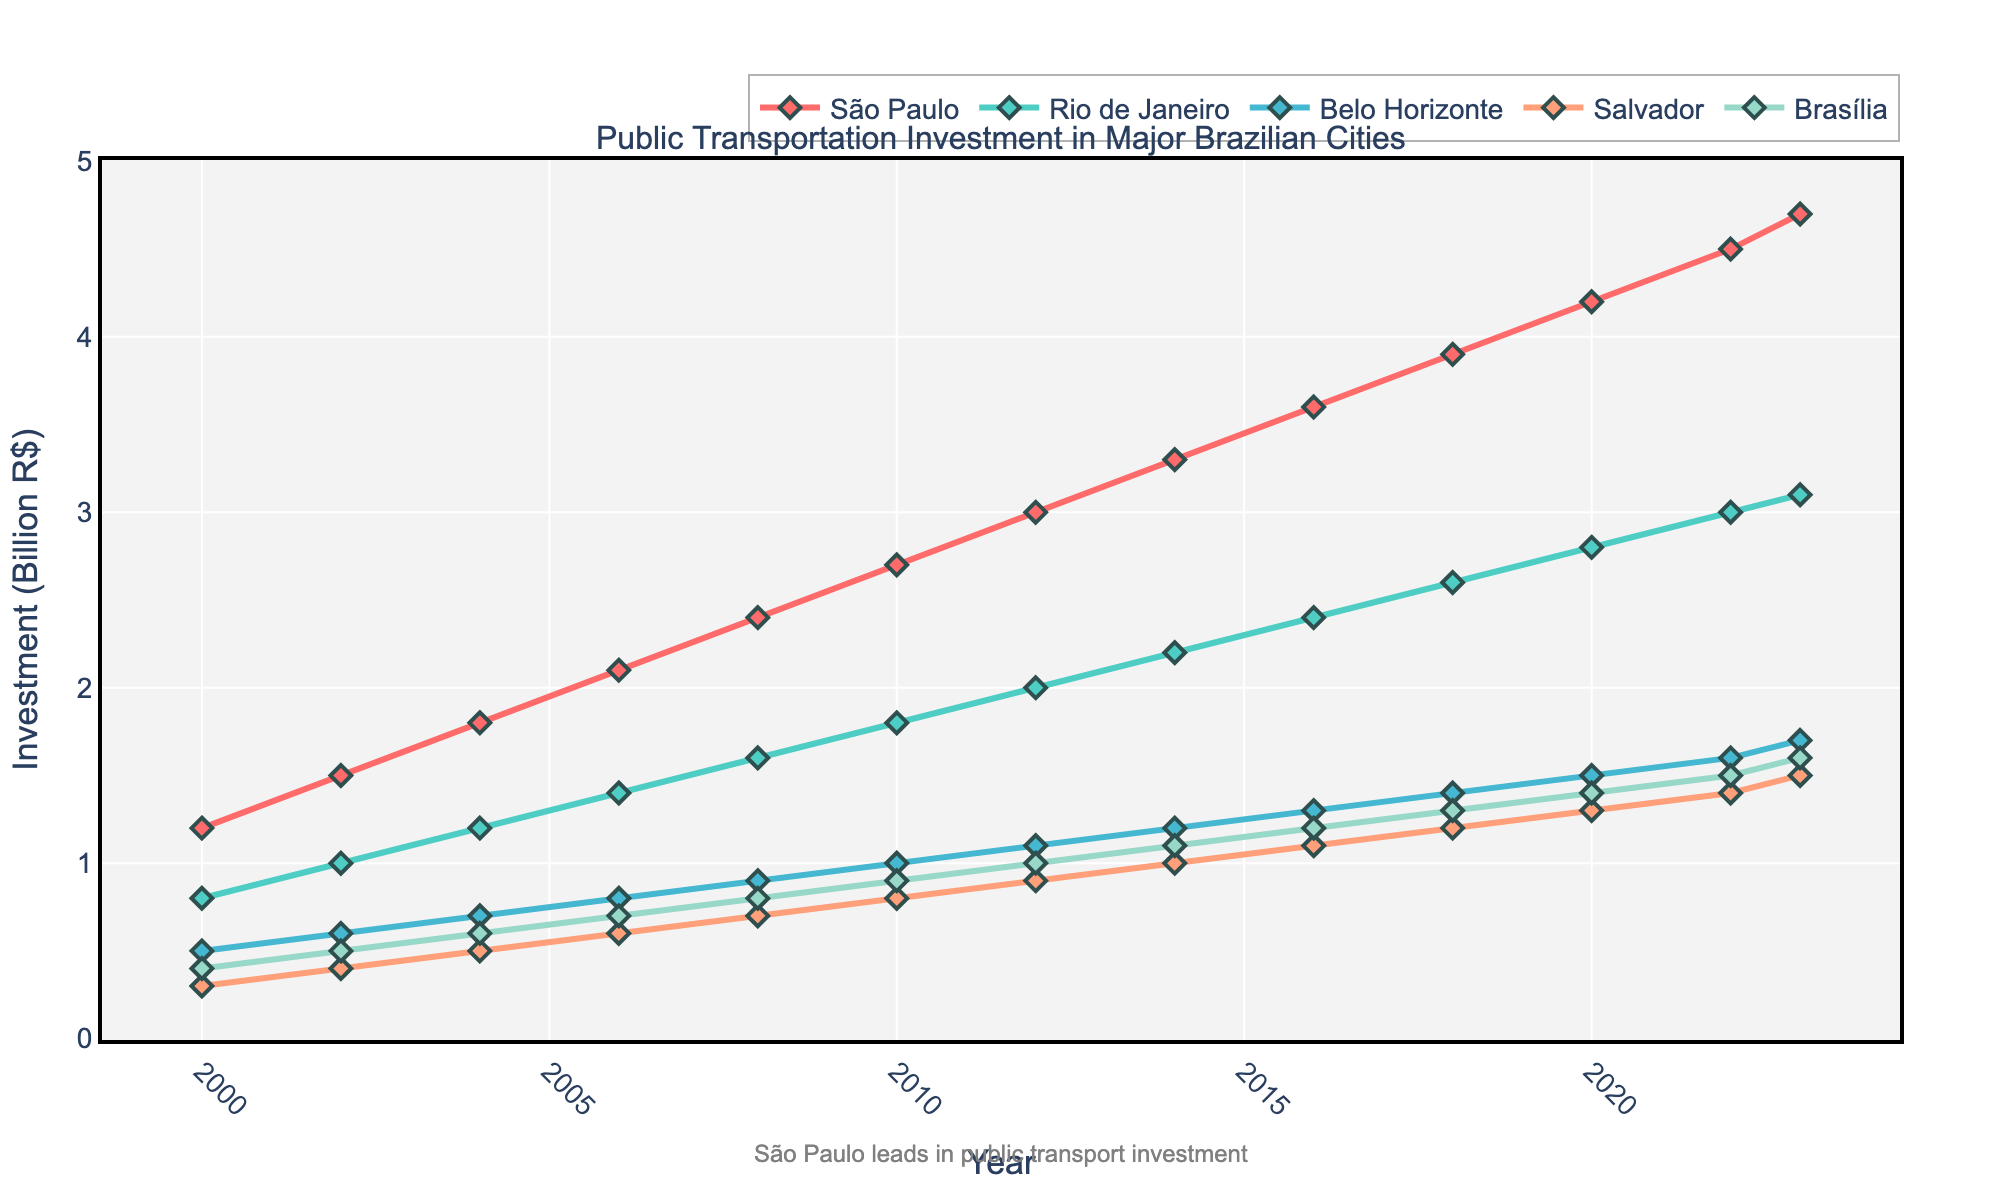Which city had the highest public transportation investment in 2023? São Paulo had the highest public transportation investment in 2023. By examining the investment trends in the chart, São Paulo's investment value is at the topmost point among all cities, indicating the highest investment.
Answer: São Paulo How much did the public transportation investment in São Paulo increase from 2010 to 2020? To find the increase in investment, subtract the 2010 value from the 2020 value for São Paulo. The values are 2.7 (2010) and 4.2 (2020). The increase is 4.2 - 2.7 = 1.5 billion R$.
Answer: 1.5 billion R$ Which city had the smallest growth in public transportation investment from 2000 to 2023? Look at the start and end points for each city. Calculate the difference between 2023 and 2000 for each city, and determine the smallest difference. Salvador’s values show the smallest increase from 0.3 to 1.5, which is an increase of 1.2 billion R$.
Answer: Salvador Between 2012 and 2022, which city had the highest average annual investment in public transportation? Calculate the average investment for each city over the years 2012 to 2022 and compare them. São Paulo’s average can be calculated by summing the values (3.0 + 3.3 + 3.6 + 3.9 + 4.2 + 4.5) and dividing by 6, resulting in the highest average among all cities.
Answer: São Paulo Which city’s investment surpassed Rio de Janeiro in 2006? To determine this, compare Rio de Janeiro’s investment values with other cities’ values in 2006. São Paulo’s investment in 2006 (2.1) was higher than Rio de Janeiro’s (1.4).
Answer: São Paulo What’s the total investment in public transportation for all cities in 2018? Sum the investment values for all cities in 2018: São Paulo (3.9), Rio de Janeiro (2.6), Belo Horizonte (1.4), Salvador (1.2), Brasília (1.3). The total is 3.9 + 2.6 + 1.4 + 1.2 + 1.3 = 10.4 billion R$.
Answer: 10.4 billion R$ By how much did the investment in Brasília increase between 2004 and 2022? Subtract the 2004 value from the 2022 value for Brasília. The values are 0.6 (2004) and 1.5 (2022). The increase is 1.5 - 0.6 = 0.9 billion R$.
Answer: 0.9 billion R$ From 2000 to 2023, which city’s public transportation investment showed the most steady growth? Visually inspect the chart for investment lines that show the most consistent upward trend without large fluctuations. São Paulo shows a steady and consistent upward trend throughout the given years.
Answer: São Paulo 